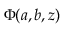Convert formula to latex. <formula><loc_0><loc_0><loc_500><loc_500>\Phi ( a , b , z )</formula> 